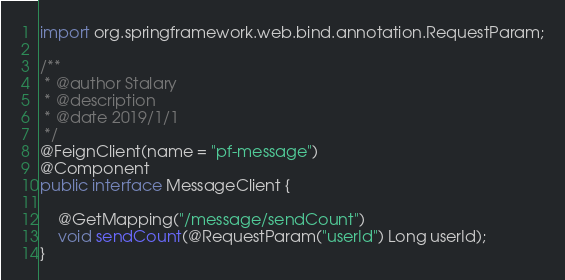<code> <loc_0><loc_0><loc_500><loc_500><_Java_>import org.springframework.web.bind.annotation.RequestParam;

/**
 * @author Stalary
 * @description
 * @date 2019/1/1
 */
@FeignClient(name = "pf-message")
@Component
public interface MessageClient {

    @GetMapping("/message/sendCount")
    void sendCount(@RequestParam("userId") Long userId);
}
</code> 